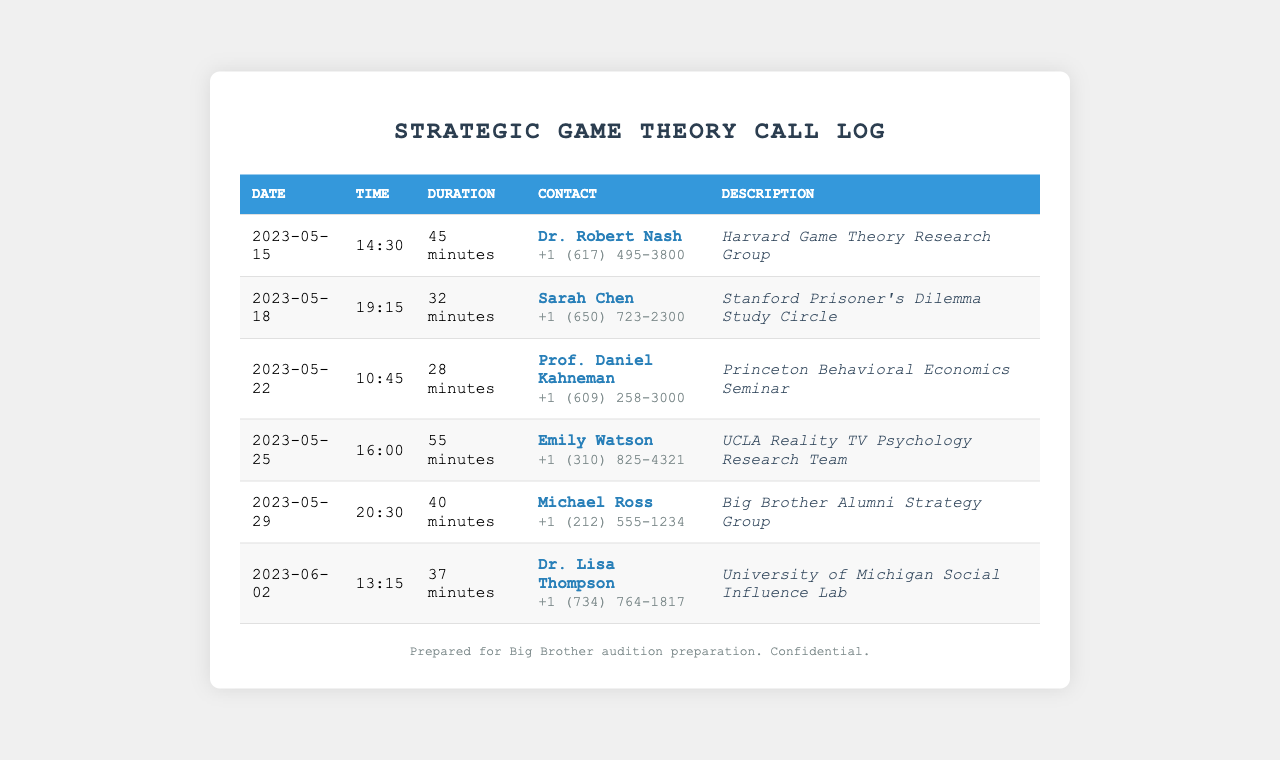What was the duration of the call with Dr. Robert Nash? The duration of the call with Dr. Robert Nash is listed in the table as 45 minutes.
Answer: 45 minutes Who is the contact for the UCLA Reality TV Psychology Research Team? The contact for the UCLA Reality TV Psychology Research Team is Emily Watson, as noted in the document.
Answer: Emily Watson On what date did the call with Michael Ross take place? The date of the call with Michael Ross is provided as 2023-05-29 in the table.
Answer: 2023-05-29 What is the duration of the call with Sarah Chen? The duration of the call with Sarah Chen is stated in the document as 32 minutes.
Answer: 32 minutes Which professor was consulted for the Princeton Behavioral Economics Seminar? The document lists Prof. Daniel Kahneman as the contact for the Princeton Behavioral Economics Seminar.
Answer: Prof. Daniel Kahneman How many minutes was the call with Dr. Lisa Thompson? The document indicates that the call with Dr. Lisa Thompson lasted for 37 minutes.
Answer: 37 minutes What type of group is associated with the contact Michael Ross? The type of group associated with Michael Ross is the Big Brother Alumni Strategy Group, mentioned in the description.
Answer: Big Brother Alumni Strategy Group Which university is Dr. Lisa Thompson affiliated with? The university associated with Dr. Lisa Thompson is the University of Michigan, as per the provided information.
Answer: University of Michigan 